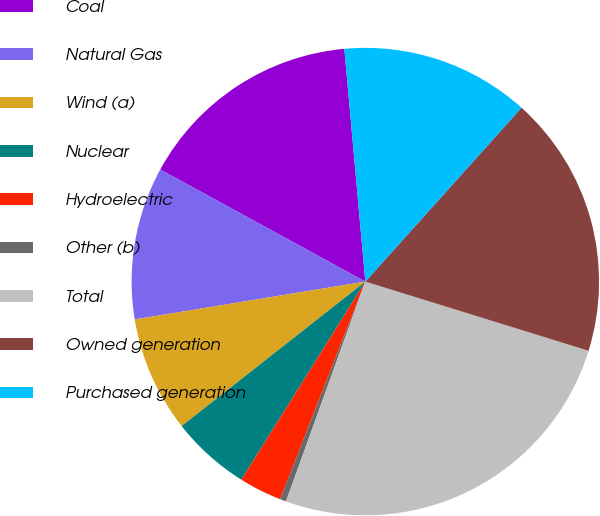Convert chart to OTSL. <chart><loc_0><loc_0><loc_500><loc_500><pie_chart><fcel>Coal<fcel>Natural Gas<fcel>Wind (a)<fcel>Nuclear<fcel>Hydroelectric<fcel>Other (b)<fcel>Total<fcel>Owned generation<fcel>Purchased generation<nl><fcel>15.61%<fcel>10.55%<fcel>8.02%<fcel>5.49%<fcel>2.96%<fcel>0.43%<fcel>25.73%<fcel>18.14%<fcel>13.08%<nl></chart> 